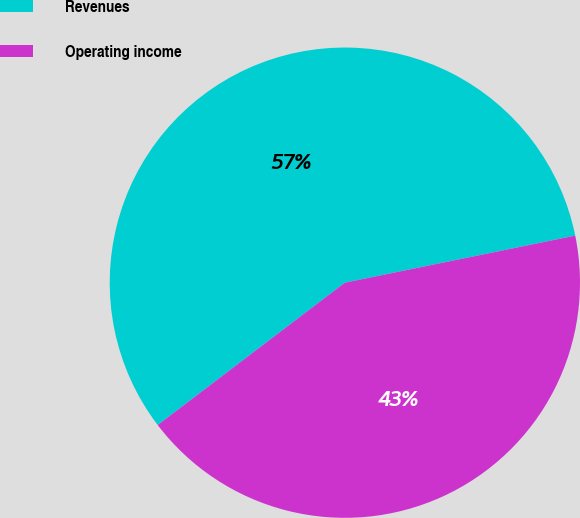<chart> <loc_0><loc_0><loc_500><loc_500><pie_chart><fcel>Revenues<fcel>Operating income<nl><fcel>57.14%<fcel>42.86%<nl></chart> 